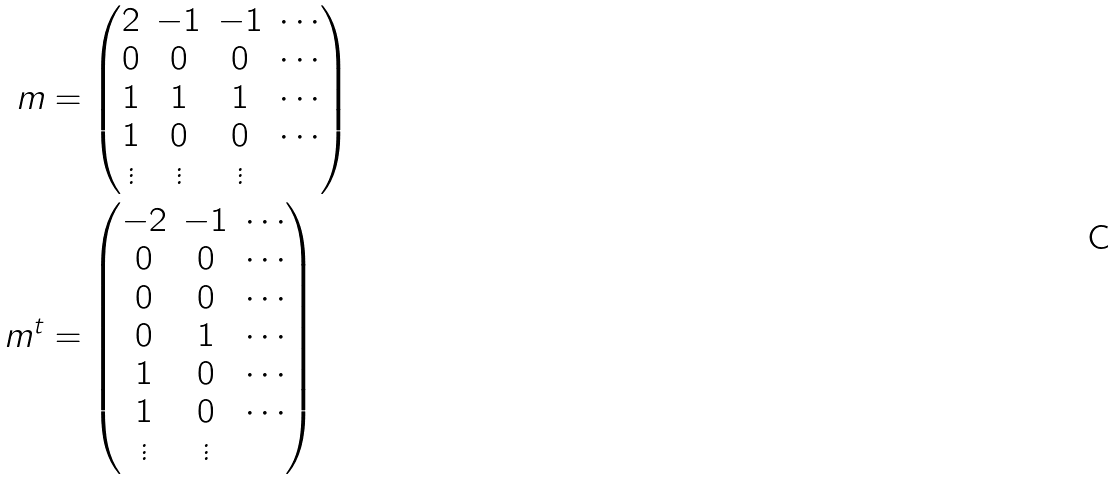Convert formula to latex. <formula><loc_0><loc_0><loc_500><loc_500>m & = \begin{pmatrix} 2 & - 1 & - 1 & \cdots \\ 0 & 0 & 0 & \cdots \\ 1 & 1 & 1 & \cdots \\ 1 & 0 & 0 & \cdots \\ \vdots & \vdots & \vdots & \end{pmatrix} \\ m ^ { t } & = \begin{pmatrix} - 2 & - 1 & \cdots \\ 0 & 0 & \cdots \\ 0 & 0 & \cdots \\ 0 & 1 & \cdots \\ 1 & 0 & \cdots \\ 1 & 0 & \cdots \\ \vdots & \vdots & \end{pmatrix}</formula> 